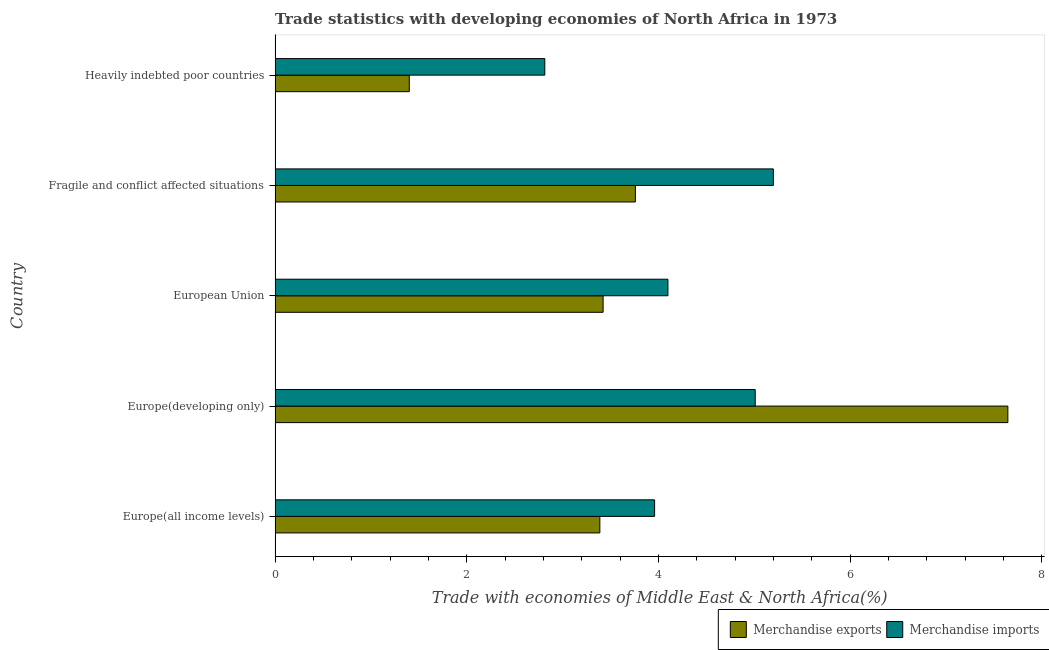How many different coloured bars are there?
Provide a short and direct response. 2. Are the number of bars per tick equal to the number of legend labels?
Ensure brevity in your answer.  Yes. How many bars are there on the 1st tick from the bottom?
Offer a terse response. 2. What is the label of the 5th group of bars from the top?
Ensure brevity in your answer.  Europe(all income levels). In how many cases, is the number of bars for a given country not equal to the number of legend labels?
Provide a short and direct response. 0. What is the merchandise imports in European Union?
Give a very brief answer. 4.1. Across all countries, what is the maximum merchandise imports?
Offer a terse response. 5.2. Across all countries, what is the minimum merchandise imports?
Make the answer very short. 2.81. In which country was the merchandise exports maximum?
Make the answer very short. Europe(developing only). In which country was the merchandise exports minimum?
Make the answer very short. Heavily indebted poor countries. What is the total merchandise imports in the graph?
Provide a short and direct response. 21.08. What is the difference between the merchandise exports in Europe(all income levels) and that in Fragile and conflict affected situations?
Your answer should be compact. -0.37. What is the difference between the merchandise imports in Europe(developing only) and the merchandise exports in Fragile and conflict affected situations?
Your response must be concise. 1.25. What is the average merchandise imports per country?
Offer a very short reply. 4.22. What is the difference between the merchandise imports and merchandise exports in Heavily indebted poor countries?
Offer a very short reply. 1.41. In how many countries, is the merchandise exports greater than 3.6 %?
Keep it short and to the point. 2. What is the ratio of the merchandise exports in Europe(developing only) to that in European Union?
Your answer should be compact. 2.23. Is the merchandise imports in Fragile and conflict affected situations less than that in Heavily indebted poor countries?
Provide a short and direct response. No. What is the difference between the highest and the second highest merchandise exports?
Your answer should be compact. 3.89. What is the difference between the highest and the lowest merchandise exports?
Your answer should be compact. 6.24. Is the sum of the merchandise exports in Europe(developing only) and European Union greater than the maximum merchandise imports across all countries?
Provide a short and direct response. Yes. How many bars are there?
Your response must be concise. 10. Are all the bars in the graph horizontal?
Give a very brief answer. Yes. How many countries are there in the graph?
Provide a succinct answer. 5. Are the values on the major ticks of X-axis written in scientific E-notation?
Your answer should be compact. No. How are the legend labels stacked?
Offer a very short reply. Horizontal. What is the title of the graph?
Make the answer very short. Trade statistics with developing economies of North Africa in 1973. What is the label or title of the X-axis?
Provide a succinct answer. Trade with economies of Middle East & North Africa(%). What is the label or title of the Y-axis?
Your response must be concise. Country. What is the Trade with economies of Middle East & North Africa(%) in Merchandise exports in Europe(all income levels)?
Give a very brief answer. 3.39. What is the Trade with economies of Middle East & North Africa(%) in Merchandise imports in Europe(all income levels)?
Your answer should be very brief. 3.96. What is the Trade with economies of Middle East & North Africa(%) of Merchandise exports in Europe(developing only)?
Ensure brevity in your answer.  7.64. What is the Trade with economies of Middle East & North Africa(%) of Merchandise imports in Europe(developing only)?
Provide a short and direct response. 5.01. What is the Trade with economies of Middle East & North Africa(%) of Merchandise exports in European Union?
Your response must be concise. 3.42. What is the Trade with economies of Middle East & North Africa(%) of Merchandise imports in European Union?
Make the answer very short. 4.1. What is the Trade with economies of Middle East & North Africa(%) in Merchandise exports in Fragile and conflict affected situations?
Your answer should be compact. 3.76. What is the Trade with economies of Middle East & North Africa(%) of Merchandise imports in Fragile and conflict affected situations?
Your answer should be compact. 5.2. What is the Trade with economies of Middle East & North Africa(%) of Merchandise exports in Heavily indebted poor countries?
Offer a terse response. 1.4. What is the Trade with economies of Middle East & North Africa(%) in Merchandise imports in Heavily indebted poor countries?
Ensure brevity in your answer.  2.81. Across all countries, what is the maximum Trade with economies of Middle East & North Africa(%) in Merchandise exports?
Keep it short and to the point. 7.64. Across all countries, what is the maximum Trade with economies of Middle East & North Africa(%) in Merchandise imports?
Offer a terse response. 5.2. Across all countries, what is the minimum Trade with economies of Middle East & North Africa(%) of Merchandise exports?
Your response must be concise. 1.4. Across all countries, what is the minimum Trade with economies of Middle East & North Africa(%) of Merchandise imports?
Make the answer very short. 2.81. What is the total Trade with economies of Middle East & North Africa(%) in Merchandise exports in the graph?
Ensure brevity in your answer.  19.61. What is the total Trade with economies of Middle East & North Africa(%) in Merchandise imports in the graph?
Give a very brief answer. 21.08. What is the difference between the Trade with economies of Middle East & North Africa(%) in Merchandise exports in Europe(all income levels) and that in Europe(developing only)?
Offer a terse response. -4.26. What is the difference between the Trade with economies of Middle East & North Africa(%) of Merchandise imports in Europe(all income levels) and that in Europe(developing only)?
Keep it short and to the point. -1.05. What is the difference between the Trade with economies of Middle East & North Africa(%) in Merchandise exports in Europe(all income levels) and that in European Union?
Provide a short and direct response. -0.03. What is the difference between the Trade with economies of Middle East & North Africa(%) of Merchandise imports in Europe(all income levels) and that in European Union?
Your response must be concise. -0.14. What is the difference between the Trade with economies of Middle East & North Africa(%) of Merchandise exports in Europe(all income levels) and that in Fragile and conflict affected situations?
Ensure brevity in your answer.  -0.37. What is the difference between the Trade with economies of Middle East & North Africa(%) of Merchandise imports in Europe(all income levels) and that in Fragile and conflict affected situations?
Keep it short and to the point. -1.24. What is the difference between the Trade with economies of Middle East & North Africa(%) of Merchandise exports in Europe(all income levels) and that in Heavily indebted poor countries?
Your response must be concise. 1.99. What is the difference between the Trade with economies of Middle East & North Africa(%) of Merchandise imports in Europe(all income levels) and that in Heavily indebted poor countries?
Give a very brief answer. 1.15. What is the difference between the Trade with economies of Middle East & North Africa(%) in Merchandise exports in Europe(developing only) and that in European Union?
Ensure brevity in your answer.  4.22. What is the difference between the Trade with economies of Middle East & North Africa(%) of Merchandise imports in Europe(developing only) and that in European Union?
Give a very brief answer. 0.91. What is the difference between the Trade with economies of Middle East & North Africa(%) in Merchandise exports in Europe(developing only) and that in Fragile and conflict affected situations?
Your answer should be compact. 3.89. What is the difference between the Trade with economies of Middle East & North Africa(%) of Merchandise imports in Europe(developing only) and that in Fragile and conflict affected situations?
Give a very brief answer. -0.19. What is the difference between the Trade with economies of Middle East & North Africa(%) of Merchandise exports in Europe(developing only) and that in Heavily indebted poor countries?
Your answer should be very brief. 6.24. What is the difference between the Trade with economies of Middle East & North Africa(%) of Merchandise imports in Europe(developing only) and that in Heavily indebted poor countries?
Ensure brevity in your answer.  2.2. What is the difference between the Trade with economies of Middle East & North Africa(%) in Merchandise exports in European Union and that in Fragile and conflict affected situations?
Offer a very short reply. -0.34. What is the difference between the Trade with economies of Middle East & North Africa(%) in Merchandise imports in European Union and that in Fragile and conflict affected situations?
Make the answer very short. -1.1. What is the difference between the Trade with economies of Middle East & North Africa(%) in Merchandise exports in European Union and that in Heavily indebted poor countries?
Provide a short and direct response. 2.02. What is the difference between the Trade with economies of Middle East & North Africa(%) of Merchandise imports in European Union and that in Heavily indebted poor countries?
Keep it short and to the point. 1.28. What is the difference between the Trade with economies of Middle East & North Africa(%) in Merchandise exports in Fragile and conflict affected situations and that in Heavily indebted poor countries?
Give a very brief answer. 2.36. What is the difference between the Trade with economies of Middle East & North Africa(%) of Merchandise imports in Fragile and conflict affected situations and that in Heavily indebted poor countries?
Keep it short and to the point. 2.38. What is the difference between the Trade with economies of Middle East & North Africa(%) of Merchandise exports in Europe(all income levels) and the Trade with economies of Middle East & North Africa(%) of Merchandise imports in Europe(developing only)?
Provide a short and direct response. -1.62. What is the difference between the Trade with economies of Middle East & North Africa(%) of Merchandise exports in Europe(all income levels) and the Trade with economies of Middle East & North Africa(%) of Merchandise imports in European Union?
Provide a short and direct response. -0.71. What is the difference between the Trade with economies of Middle East & North Africa(%) in Merchandise exports in Europe(all income levels) and the Trade with economies of Middle East & North Africa(%) in Merchandise imports in Fragile and conflict affected situations?
Your answer should be very brief. -1.81. What is the difference between the Trade with economies of Middle East & North Africa(%) in Merchandise exports in Europe(all income levels) and the Trade with economies of Middle East & North Africa(%) in Merchandise imports in Heavily indebted poor countries?
Provide a short and direct response. 0.57. What is the difference between the Trade with economies of Middle East & North Africa(%) of Merchandise exports in Europe(developing only) and the Trade with economies of Middle East & North Africa(%) of Merchandise imports in European Union?
Provide a succinct answer. 3.55. What is the difference between the Trade with economies of Middle East & North Africa(%) of Merchandise exports in Europe(developing only) and the Trade with economies of Middle East & North Africa(%) of Merchandise imports in Fragile and conflict affected situations?
Your response must be concise. 2.45. What is the difference between the Trade with economies of Middle East & North Africa(%) of Merchandise exports in Europe(developing only) and the Trade with economies of Middle East & North Africa(%) of Merchandise imports in Heavily indebted poor countries?
Provide a succinct answer. 4.83. What is the difference between the Trade with economies of Middle East & North Africa(%) in Merchandise exports in European Union and the Trade with economies of Middle East & North Africa(%) in Merchandise imports in Fragile and conflict affected situations?
Make the answer very short. -1.78. What is the difference between the Trade with economies of Middle East & North Africa(%) of Merchandise exports in European Union and the Trade with economies of Middle East & North Africa(%) of Merchandise imports in Heavily indebted poor countries?
Give a very brief answer. 0.61. What is the difference between the Trade with economies of Middle East & North Africa(%) in Merchandise exports in Fragile and conflict affected situations and the Trade with economies of Middle East & North Africa(%) in Merchandise imports in Heavily indebted poor countries?
Give a very brief answer. 0.95. What is the average Trade with economies of Middle East & North Africa(%) in Merchandise exports per country?
Your answer should be compact. 3.92. What is the average Trade with economies of Middle East & North Africa(%) of Merchandise imports per country?
Provide a short and direct response. 4.22. What is the difference between the Trade with economies of Middle East & North Africa(%) in Merchandise exports and Trade with economies of Middle East & North Africa(%) in Merchandise imports in Europe(all income levels)?
Your response must be concise. -0.57. What is the difference between the Trade with economies of Middle East & North Africa(%) in Merchandise exports and Trade with economies of Middle East & North Africa(%) in Merchandise imports in Europe(developing only)?
Make the answer very short. 2.64. What is the difference between the Trade with economies of Middle East & North Africa(%) of Merchandise exports and Trade with economies of Middle East & North Africa(%) of Merchandise imports in European Union?
Offer a terse response. -0.68. What is the difference between the Trade with economies of Middle East & North Africa(%) of Merchandise exports and Trade with economies of Middle East & North Africa(%) of Merchandise imports in Fragile and conflict affected situations?
Your answer should be very brief. -1.44. What is the difference between the Trade with economies of Middle East & North Africa(%) of Merchandise exports and Trade with economies of Middle East & North Africa(%) of Merchandise imports in Heavily indebted poor countries?
Your answer should be very brief. -1.41. What is the ratio of the Trade with economies of Middle East & North Africa(%) in Merchandise exports in Europe(all income levels) to that in Europe(developing only)?
Keep it short and to the point. 0.44. What is the ratio of the Trade with economies of Middle East & North Africa(%) in Merchandise imports in Europe(all income levels) to that in Europe(developing only)?
Your answer should be compact. 0.79. What is the ratio of the Trade with economies of Middle East & North Africa(%) in Merchandise imports in Europe(all income levels) to that in European Union?
Offer a terse response. 0.97. What is the ratio of the Trade with economies of Middle East & North Africa(%) in Merchandise exports in Europe(all income levels) to that in Fragile and conflict affected situations?
Make the answer very short. 0.9. What is the ratio of the Trade with economies of Middle East & North Africa(%) of Merchandise imports in Europe(all income levels) to that in Fragile and conflict affected situations?
Make the answer very short. 0.76. What is the ratio of the Trade with economies of Middle East & North Africa(%) of Merchandise exports in Europe(all income levels) to that in Heavily indebted poor countries?
Offer a terse response. 2.42. What is the ratio of the Trade with economies of Middle East & North Africa(%) in Merchandise imports in Europe(all income levels) to that in Heavily indebted poor countries?
Your answer should be compact. 1.41. What is the ratio of the Trade with economies of Middle East & North Africa(%) of Merchandise exports in Europe(developing only) to that in European Union?
Offer a very short reply. 2.23. What is the ratio of the Trade with economies of Middle East & North Africa(%) in Merchandise imports in Europe(developing only) to that in European Union?
Your answer should be compact. 1.22. What is the ratio of the Trade with economies of Middle East & North Africa(%) in Merchandise exports in Europe(developing only) to that in Fragile and conflict affected situations?
Keep it short and to the point. 2.03. What is the ratio of the Trade with economies of Middle East & North Africa(%) in Merchandise imports in Europe(developing only) to that in Fragile and conflict affected situations?
Provide a succinct answer. 0.96. What is the ratio of the Trade with economies of Middle East & North Africa(%) in Merchandise exports in Europe(developing only) to that in Heavily indebted poor countries?
Provide a succinct answer. 5.46. What is the ratio of the Trade with economies of Middle East & North Africa(%) of Merchandise imports in Europe(developing only) to that in Heavily indebted poor countries?
Offer a very short reply. 1.78. What is the ratio of the Trade with economies of Middle East & North Africa(%) in Merchandise exports in European Union to that in Fragile and conflict affected situations?
Keep it short and to the point. 0.91. What is the ratio of the Trade with economies of Middle East & North Africa(%) in Merchandise imports in European Union to that in Fragile and conflict affected situations?
Offer a terse response. 0.79. What is the ratio of the Trade with economies of Middle East & North Africa(%) in Merchandise exports in European Union to that in Heavily indebted poor countries?
Your answer should be compact. 2.44. What is the ratio of the Trade with economies of Middle East & North Africa(%) in Merchandise imports in European Union to that in Heavily indebted poor countries?
Give a very brief answer. 1.46. What is the ratio of the Trade with economies of Middle East & North Africa(%) in Merchandise exports in Fragile and conflict affected situations to that in Heavily indebted poor countries?
Ensure brevity in your answer.  2.68. What is the ratio of the Trade with economies of Middle East & North Africa(%) of Merchandise imports in Fragile and conflict affected situations to that in Heavily indebted poor countries?
Your answer should be compact. 1.85. What is the difference between the highest and the second highest Trade with economies of Middle East & North Africa(%) of Merchandise exports?
Your answer should be very brief. 3.89. What is the difference between the highest and the second highest Trade with economies of Middle East & North Africa(%) of Merchandise imports?
Give a very brief answer. 0.19. What is the difference between the highest and the lowest Trade with economies of Middle East & North Africa(%) in Merchandise exports?
Keep it short and to the point. 6.24. What is the difference between the highest and the lowest Trade with economies of Middle East & North Africa(%) of Merchandise imports?
Make the answer very short. 2.38. 